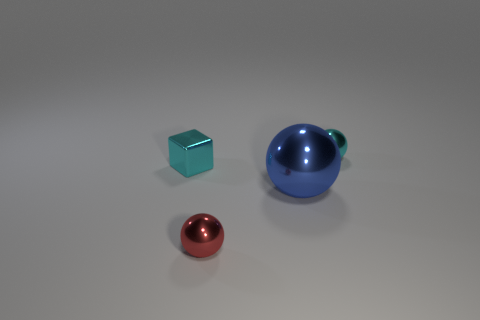There is a tiny thing that is the same color as the small cube; what is its material?
Your answer should be very brief. Metal. What color is the thing to the left of the red metal thing?
Your answer should be compact. Cyan. There is a metal ball behind the block; is it the same size as the cube?
Give a very brief answer. Yes. The metal ball that is the same color as the tiny shiny cube is what size?
Provide a short and direct response. Small. Are there any cyan metallic spheres that have the same size as the red sphere?
Make the answer very short. Yes. There is a shiny object that is on the right side of the big blue metal sphere; does it have the same color as the tiny shiny thing to the left of the red ball?
Your answer should be very brief. Yes. Is there a small shiny object that has the same color as the small cube?
Give a very brief answer. Yes. How many other objects are the same shape as the blue thing?
Your answer should be compact. 2. There is a small thing that is in front of the large metal ball; what is its shape?
Provide a short and direct response. Sphere. Do the small red thing and the metallic object that is on the left side of the red metal thing have the same shape?
Provide a short and direct response. No. 